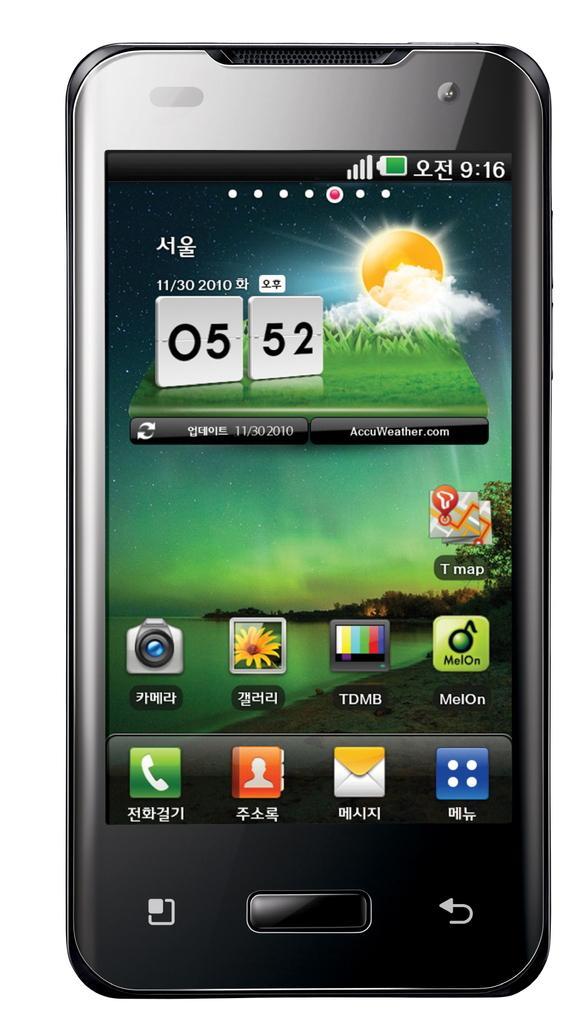Could you give a brief overview of what you see in this image? In this image there is a mobile. 